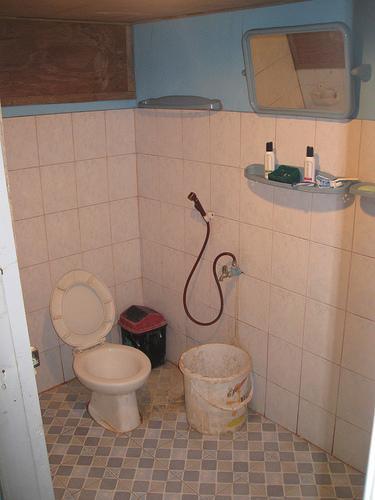How many bottles are in the picture?
Give a very brief answer. 2. 